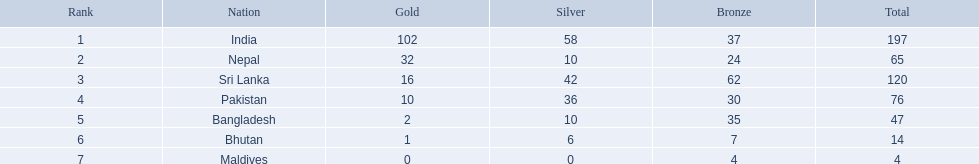In which nations were successful in obtaining medals? India, Nepal, Sri Lanka, Pakistan, Bangladesh, Bhutan, Maldives. Which country secured the highest number? India. Which had the least? Maldives. Which countries participated in the 1999 south asian games? India, Nepal, Sri Lanka, Pakistan, Bangladesh, Bhutan, Maldives. Which nation appears second on the list? Nepal. 